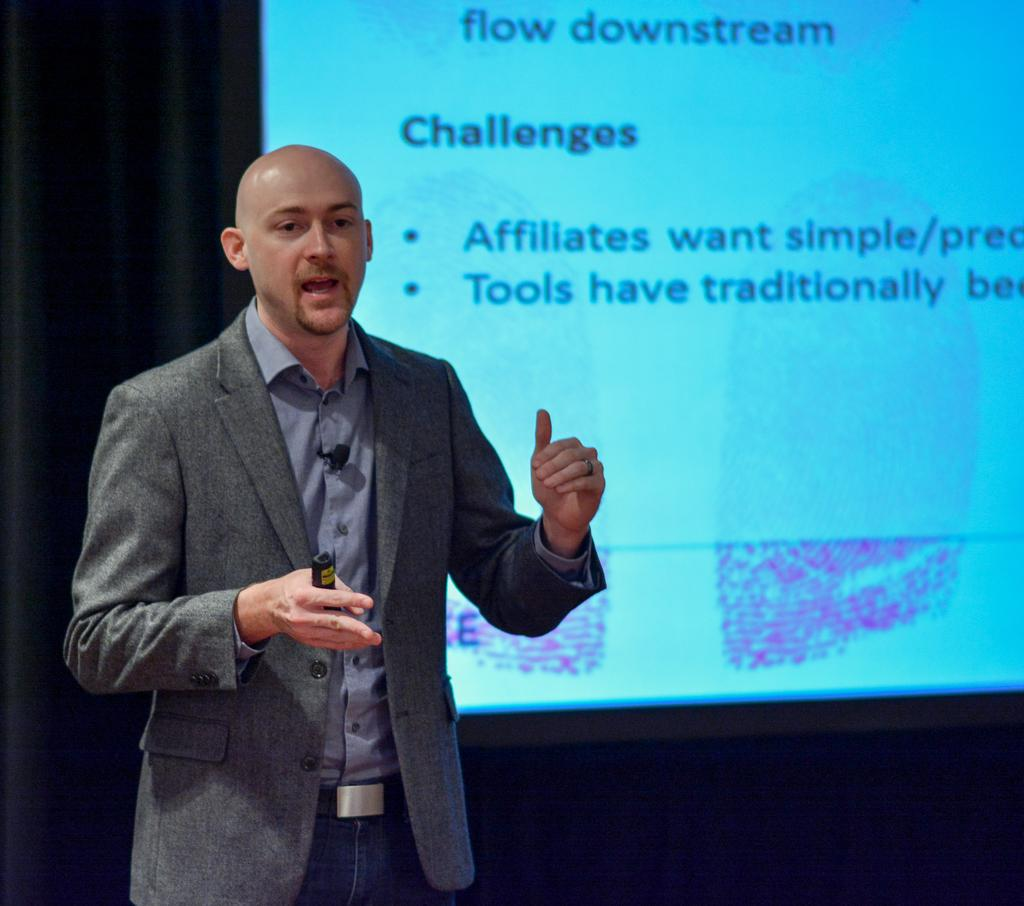What is the position of the man in the image? The man is standing on the left side of the image. What is the man wearing in the image? The man is wearing a coat in the image. What is the man holding in his hand in the image? The man is holding an object in his hand in the image. What can be seen in the background of the image? There is a projector screen in the background of the image. How many pizzas are being served on the yoke in the image? There are no pizzas or yokes present in the image. What type of meat is being cooked on the projector screen in the image? There is no meat being cooked on the projector screen in the image; it is a screen for displaying visual content. 